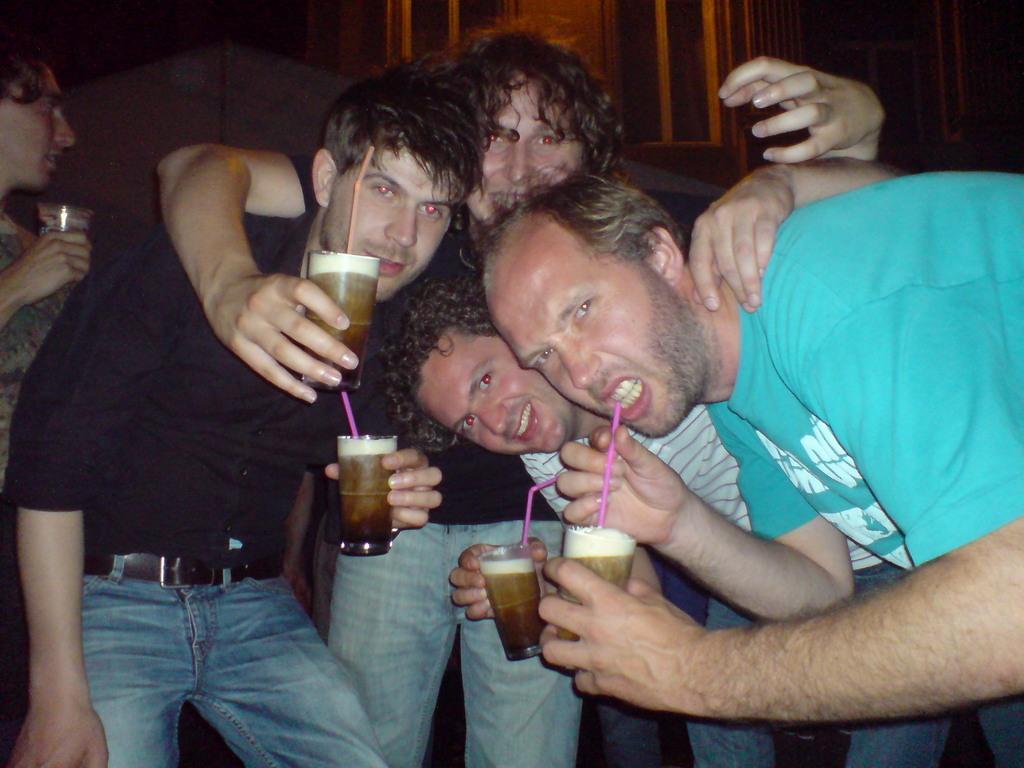Could you give a brief overview of what you see in this image? In this image we can see men standing on the floor and holding beverage glasses in their hands. 